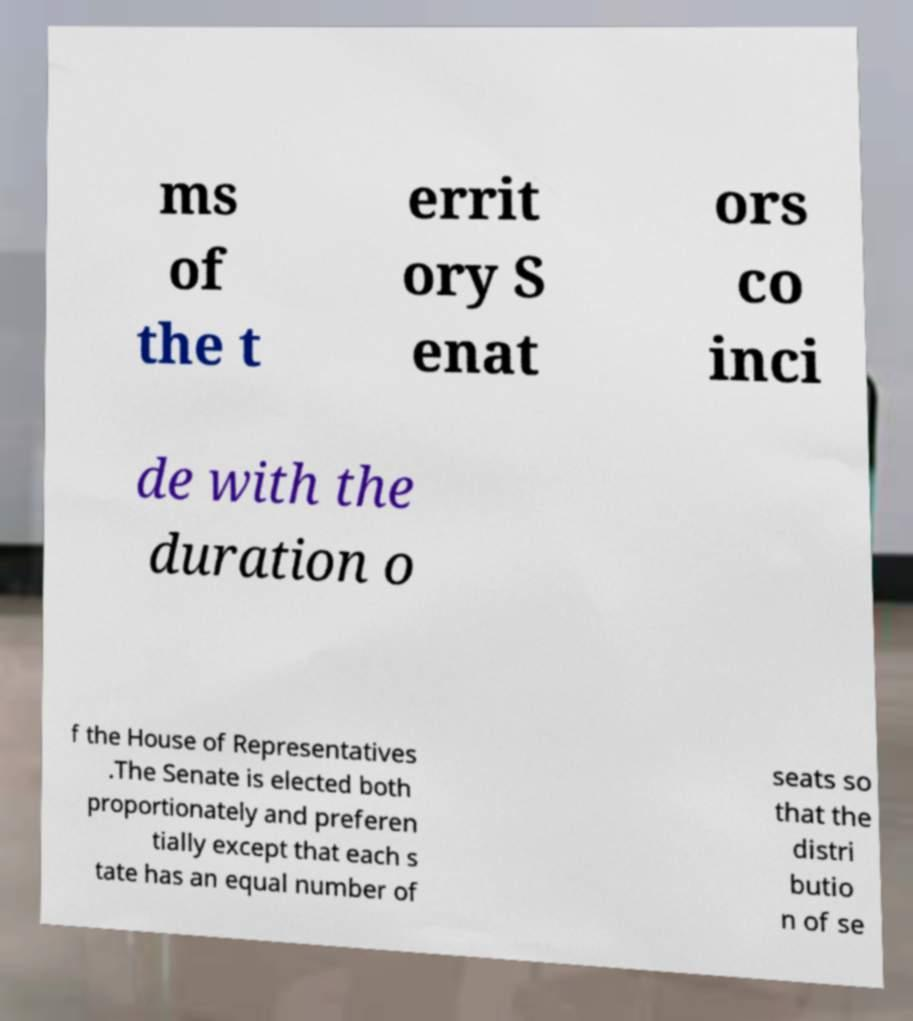Can you read and provide the text displayed in the image?This photo seems to have some interesting text. Can you extract and type it out for me? ms of the t errit ory S enat ors co inci de with the duration o f the House of Representatives .The Senate is elected both proportionately and preferen tially except that each s tate has an equal number of seats so that the distri butio n of se 